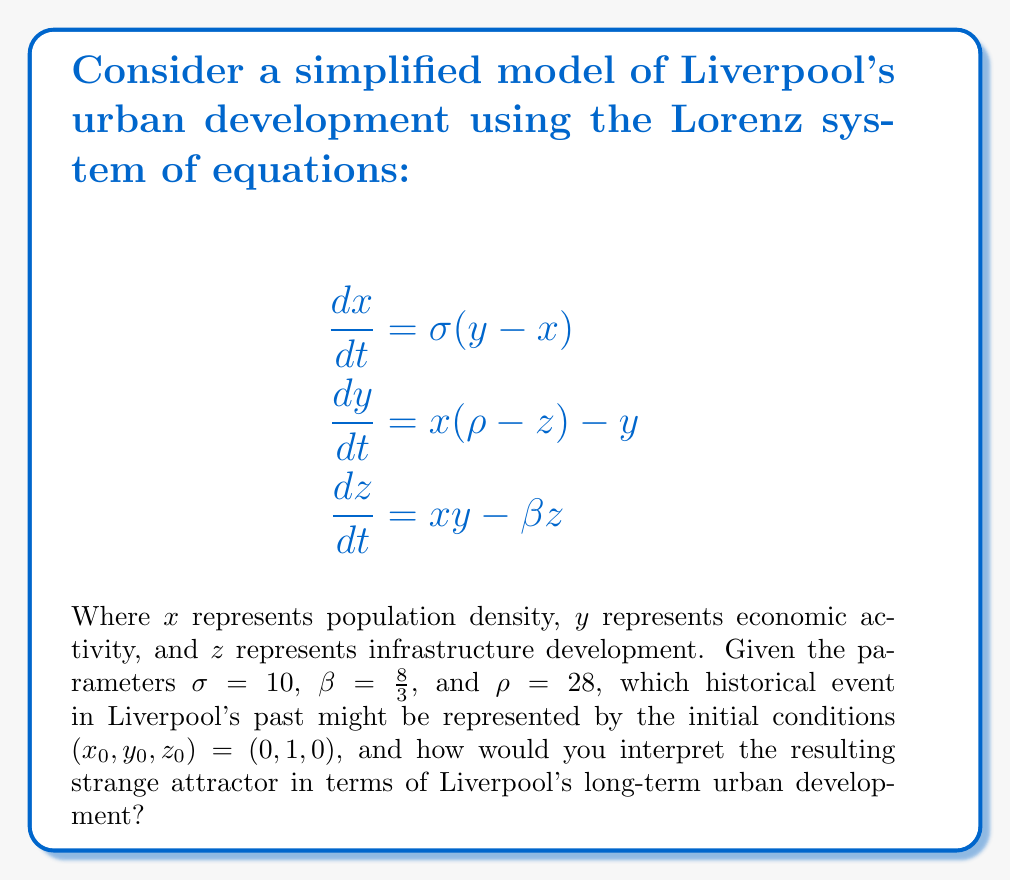Can you solve this math problem? To answer this question, we need to follow these steps:

1. Understand the Lorenz system and its parameters:
   The Lorenz system is a set of differential equations that can model complex, chaotic behavior. In this context:
   - $\sigma$ (sigma) represents the speed of the system's response to changes
   - $\beta$ (beta) represents the rate of infrastructure decay
   - $\rho$ (rho) represents the difference in temperature between the top and bottom of the system (in this case, it could represent socioeconomic disparities)

2. Interpret the initial conditions:
   $(x_0, y_0, z_0) = (0, 1, 0)$ suggests a starting point with:
   - No significant population density ($x_0 = 0$)
   - Some economic activity ($y_0 = 1$)
   - No infrastructure development ($z_0 = 0$)

   This could represent the early stages of Liverpool's development, possibly around the time it was granted its charter in 1207. At this point, it was a small settlement with some trade activity but little urban infrastructure.

3. Understand the strange attractor:
   With the given parameters, the Lorenz system produces a butterfly-shaped strange attractor. In the context of urban development, this suggests:
   - Long-term unpredictability in specific outcomes
   - Alternating periods of growth and decline
   - Sensitivity to initial conditions (small changes can lead to significantly different long-term outcomes)

4. Interpret the attractor for Liverpool's development:
   - The two "wings" of the attractor could represent periods of expansion and contraction in Liverpool's urban development.
   - The system never settles into a stable state, reflecting the constant change in urban environments.
   - The trajectories switching between the wings could represent major shifts in Liverpool's history, such as the industrial revolution, maritime trade boom, and post-industrial transformation.

5. Historical context:
   As a history teacher specializing in Liverpool's local history, you could relate this model to key events such as:
   - The opening of the world's first commercial wet dock in 1715
   - The rapid growth during the Industrial Revolution
   - The decline of the port in the mid-20th century
   - The urban regeneration efforts in recent decades

The strange attractor suggests that while these events had significant impacts, the long-term development of Liverpool follows a complex, non-linear pattern that is inherently difficult to predict precisely.
Answer: The initial conditions likely represent Liverpool's early settlement (c. 1207). The strange attractor indicates long-term urban development characterized by alternating periods of growth and decline, sensitivity to historical events, and inherent unpredictability in specific outcomes. 